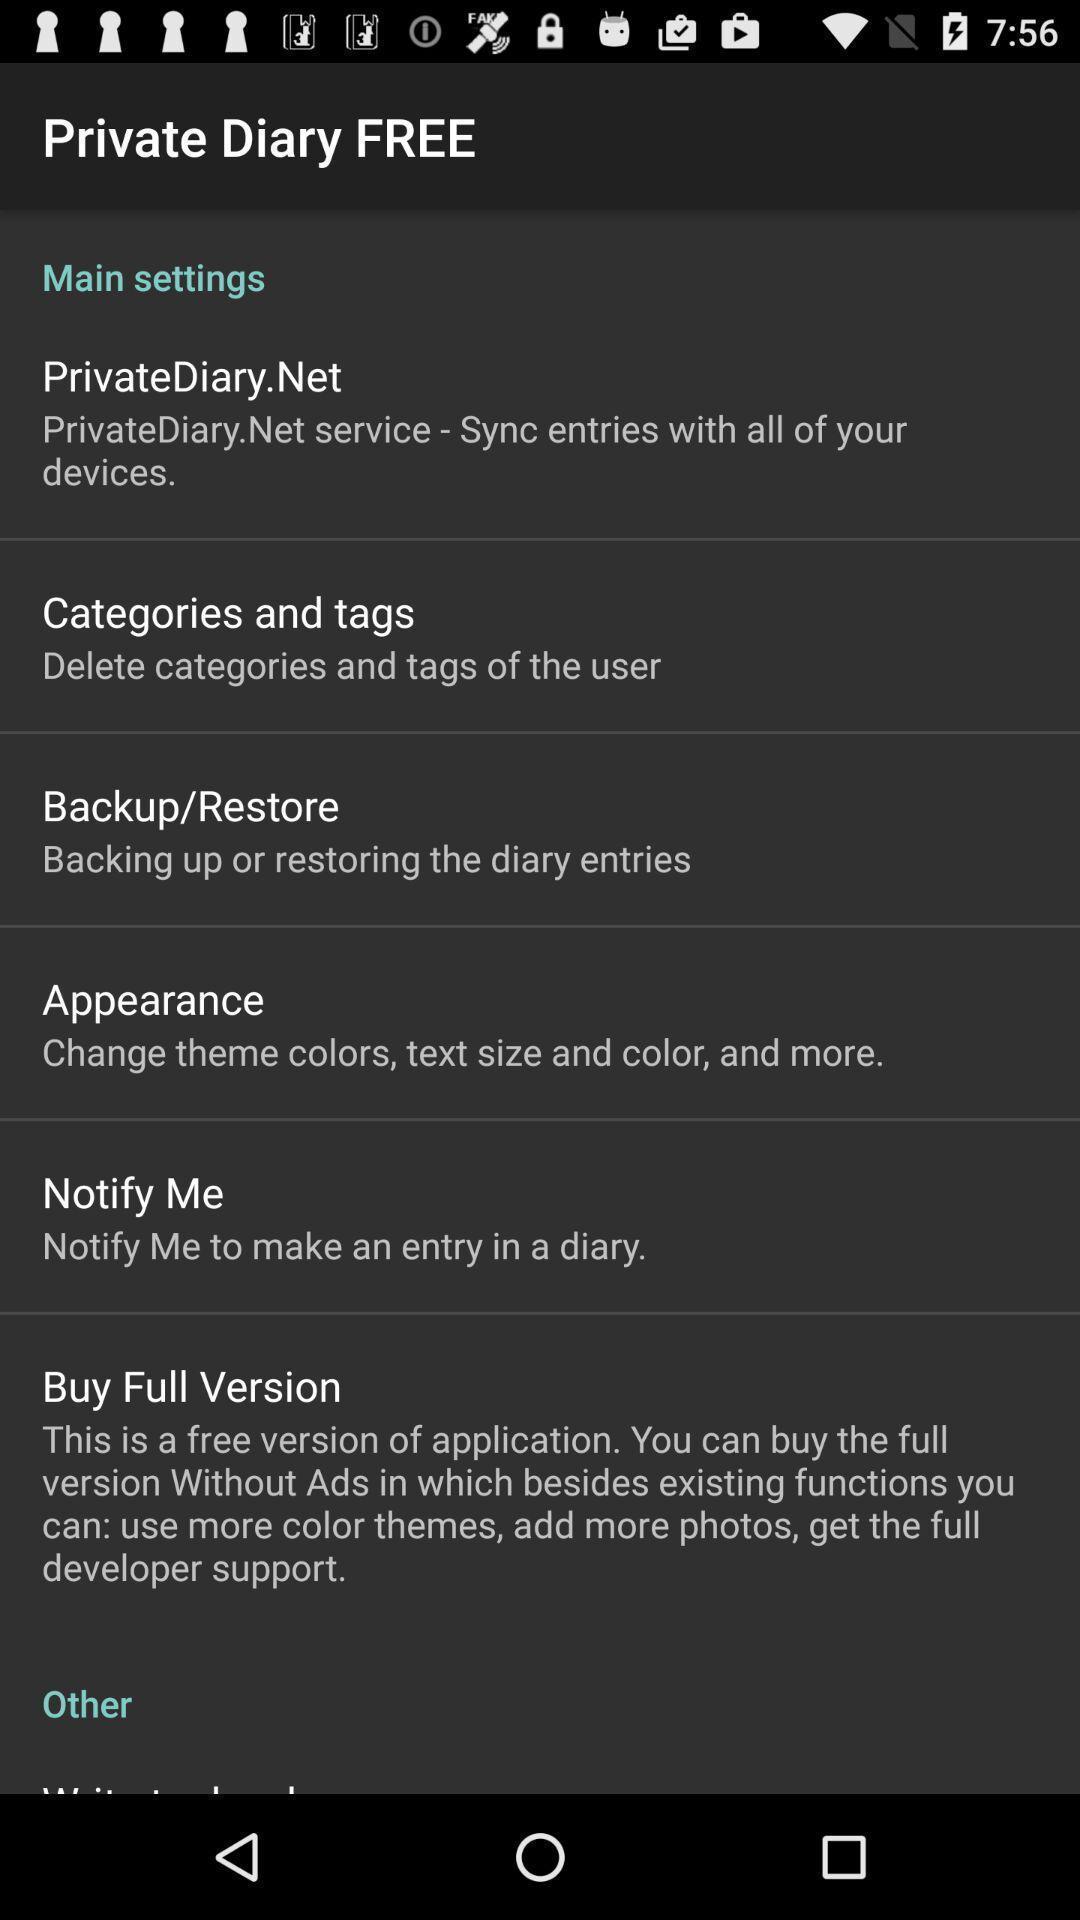Provide a detailed account of this screenshot. Settings page for an application. 